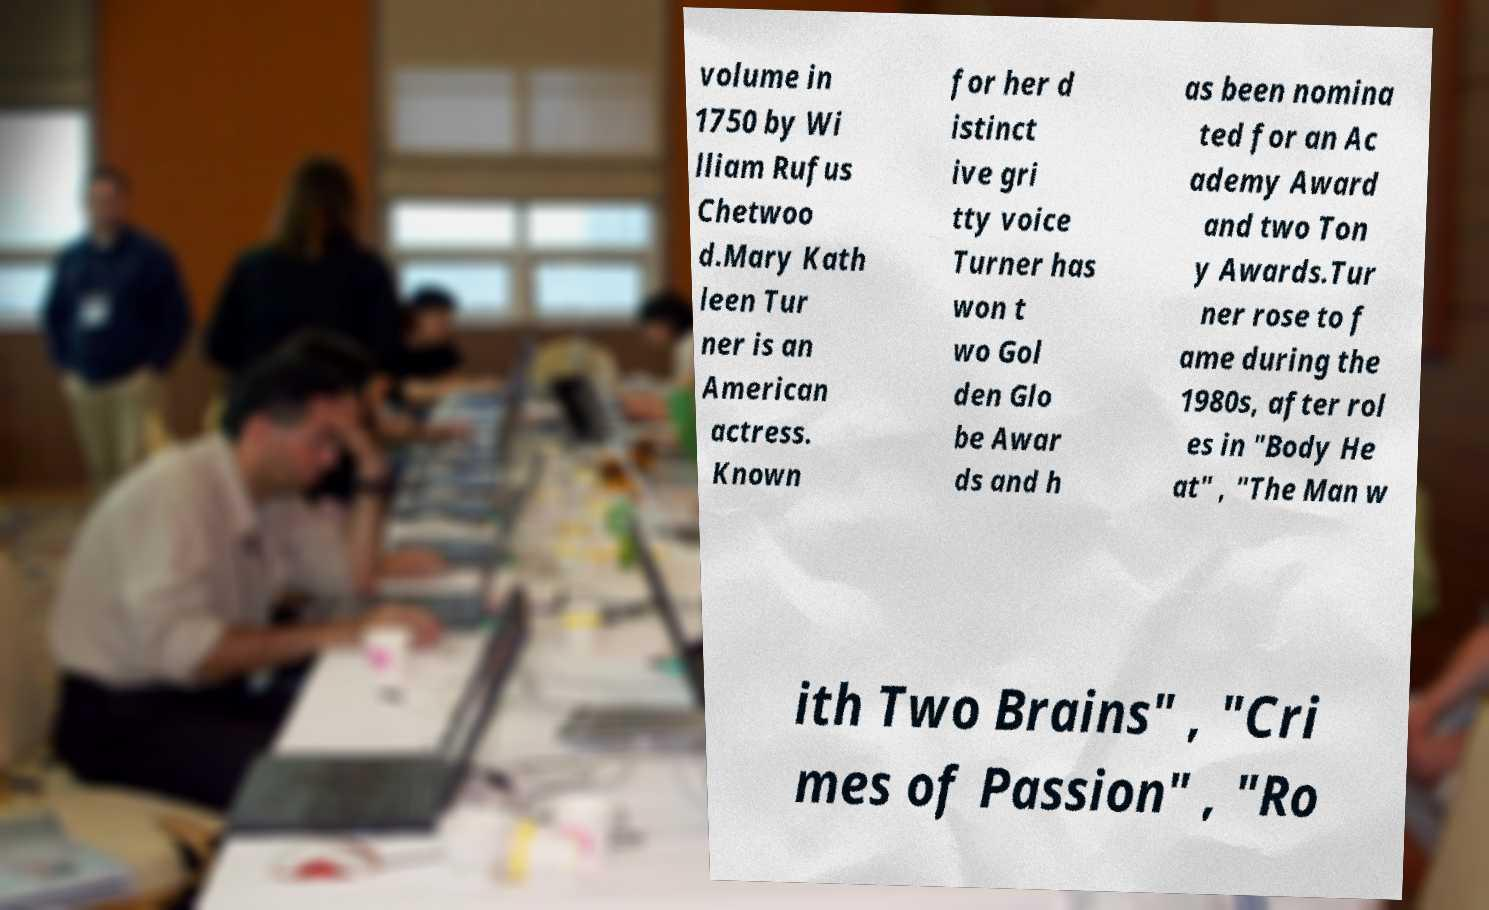There's text embedded in this image that I need extracted. Can you transcribe it verbatim? volume in 1750 by Wi lliam Rufus Chetwoo d.Mary Kath leen Tur ner is an American actress. Known for her d istinct ive gri tty voice Turner has won t wo Gol den Glo be Awar ds and h as been nomina ted for an Ac ademy Award and two Ton y Awards.Tur ner rose to f ame during the 1980s, after rol es in "Body He at" , "The Man w ith Two Brains" , "Cri mes of Passion" , "Ro 